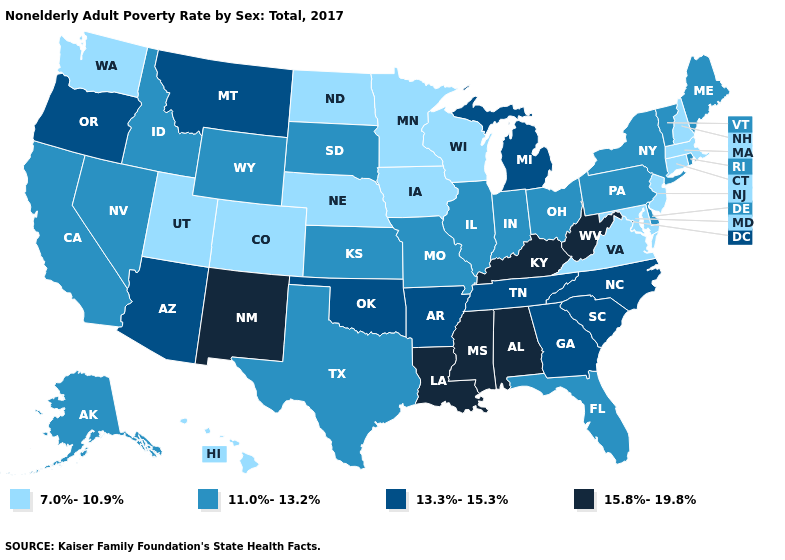Does North Carolina have the same value as Oregon?
Short answer required. Yes. What is the value of Mississippi?
Answer briefly. 15.8%-19.8%. What is the value of Utah?
Give a very brief answer. 7.0%-10.9%. What is the highest value in the MidWest ?
Give a very brief answer. 13.3%-15.3%. Name the states that have a value in the range 7.0%-10.9%?
Short answer required. Colorado, Connecticut, Hawaii, Iowa, Maryland, Massachusetts, Minnesota, Nebraska, New Hampshire, New Jersey, North Dakota, Utah, Virginia, Washington, Wisconsin. Name the states that have a value in the range 7.0%-10.9%?
Write a very short answer. Colorado, Connecticut, Hawaii, Iowa, Maryland, Massachusetts, Minnesota, Nebraska, New Hampshire, New Jersey, North Dakota, Utah, Virginia, Washington, Wisconsin. What is the lowest value in the USA?
Keep it brief. 7.0%-10.9%. What is the value of Missouri?
Be succinct. 11.0%-13.2%. Does Louisiana have the highest value in the South?
Be succinct. Yes. Does West Virginia have the lowest value in the USA?
Give a very brief answer. No. Name the states that have a value in the range 7.0%-10.9%?
Concise answer only. Colorado, Connecticut, Hawaii, Iowa, Maryland, Massachusetts, Minnesota, Nebraska, New Hampshire, New Jersey, North Dakota, Utah, Virginia, Washington, Wisconsin. What is the value of Iowa?
Answer briefly. 7.0%-10.9%. Which states have the highest value in the USA?
Answer briefly. Alabama, Kentucky, Louisiana, Mississippi, New Mexico, West Virginia. Does New York have the lowest value in the Northeast?
Short answer required. No. 